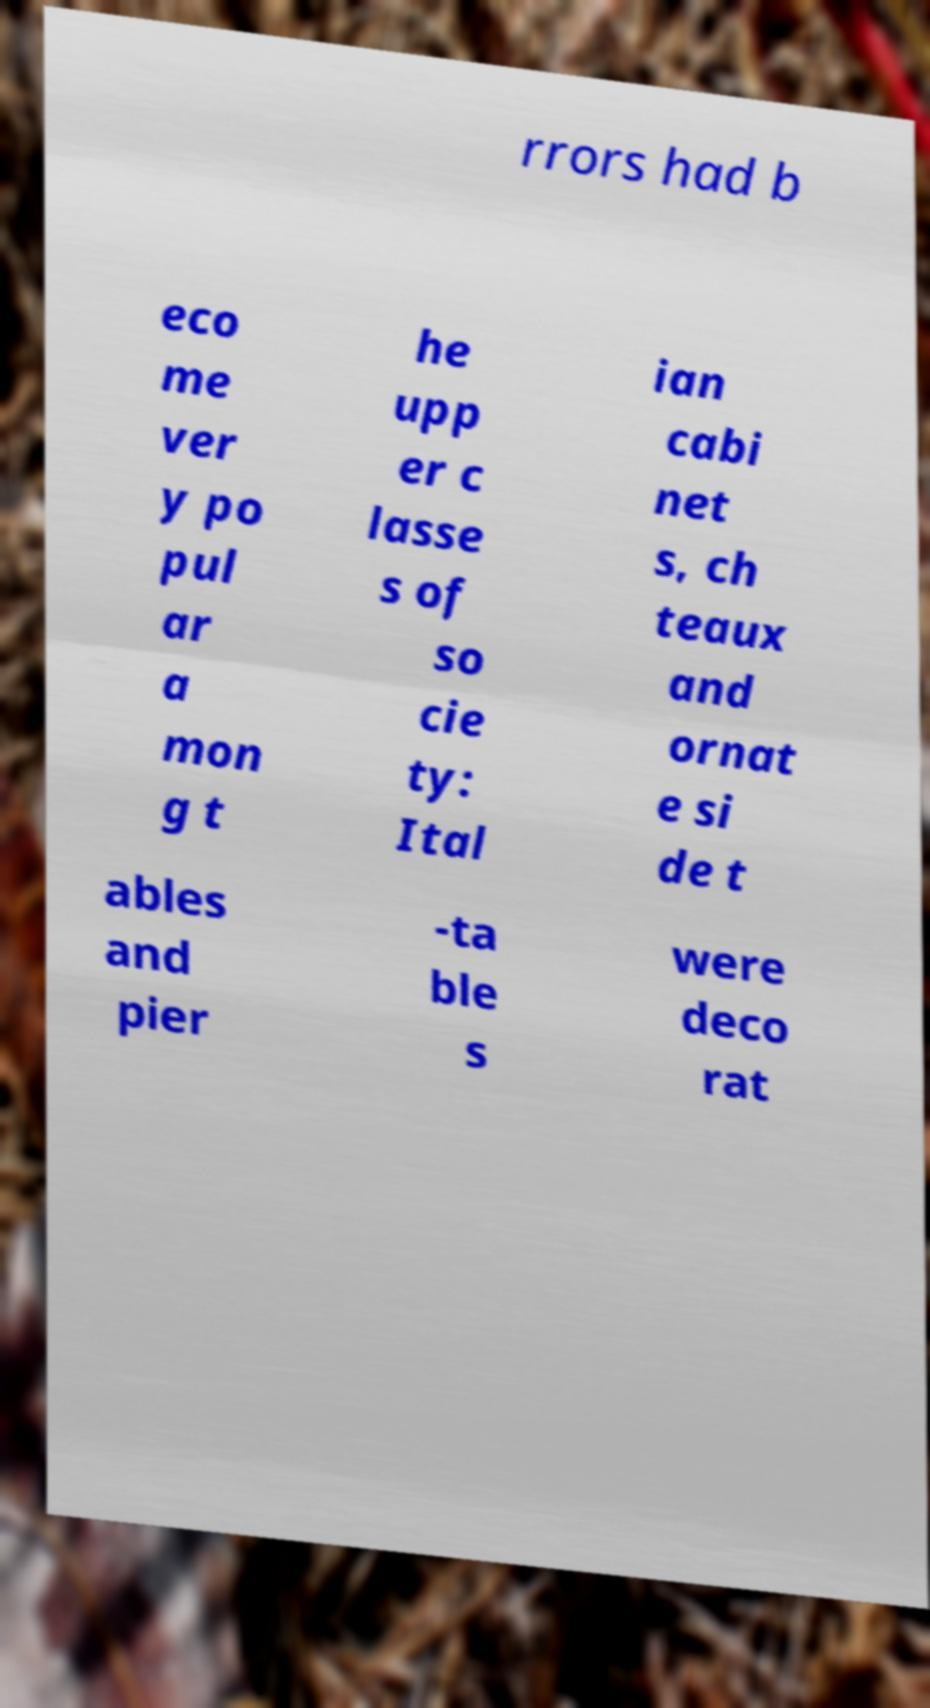Please read and relay the text visible in this image. What does it say? rrors had b eco me ver y po pul ar a mon g t he upp er c lasse s of so cie ty: Ital ian cabi net s, ch teaux and ornat e si de t ables and pier -ta ble s were deco rat 